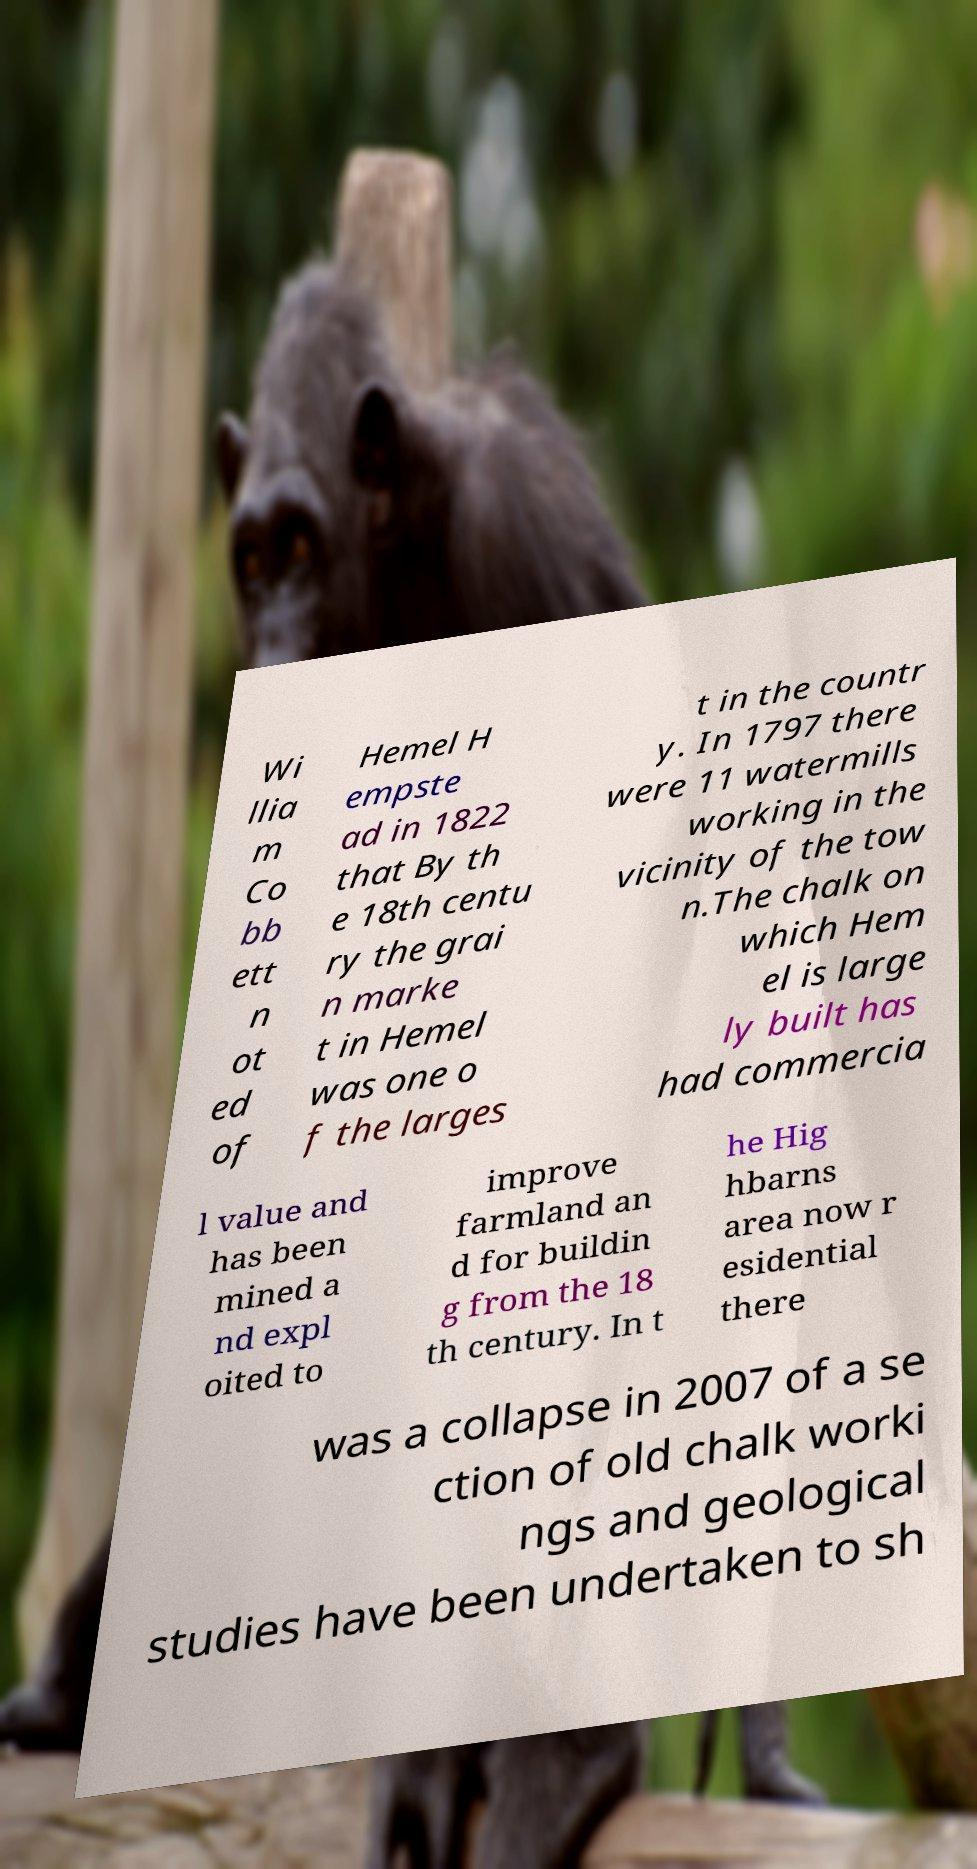For documentation purposes, I need the text within this image transcribed. Could you provide that? Wi llia m Co bb ett n ot ed of Hemel H empste ad in 1822 that By th e 18th centu ry the grai n marke t in Hemel was one o f the larges t in the countr y. In 1797 there were 11 watermills working in the vicinity of the tow n.The chalk on which Hem el is large ly built has had commercia l value and has been mined a nd expl oited to improve farmland an d for buildin g from the 18 th century. In t he Hig hbarns area now r esidential there was a collapse in 2007 of a se ction of old chalk worki ngs and geological studies have been undertaken to sh 